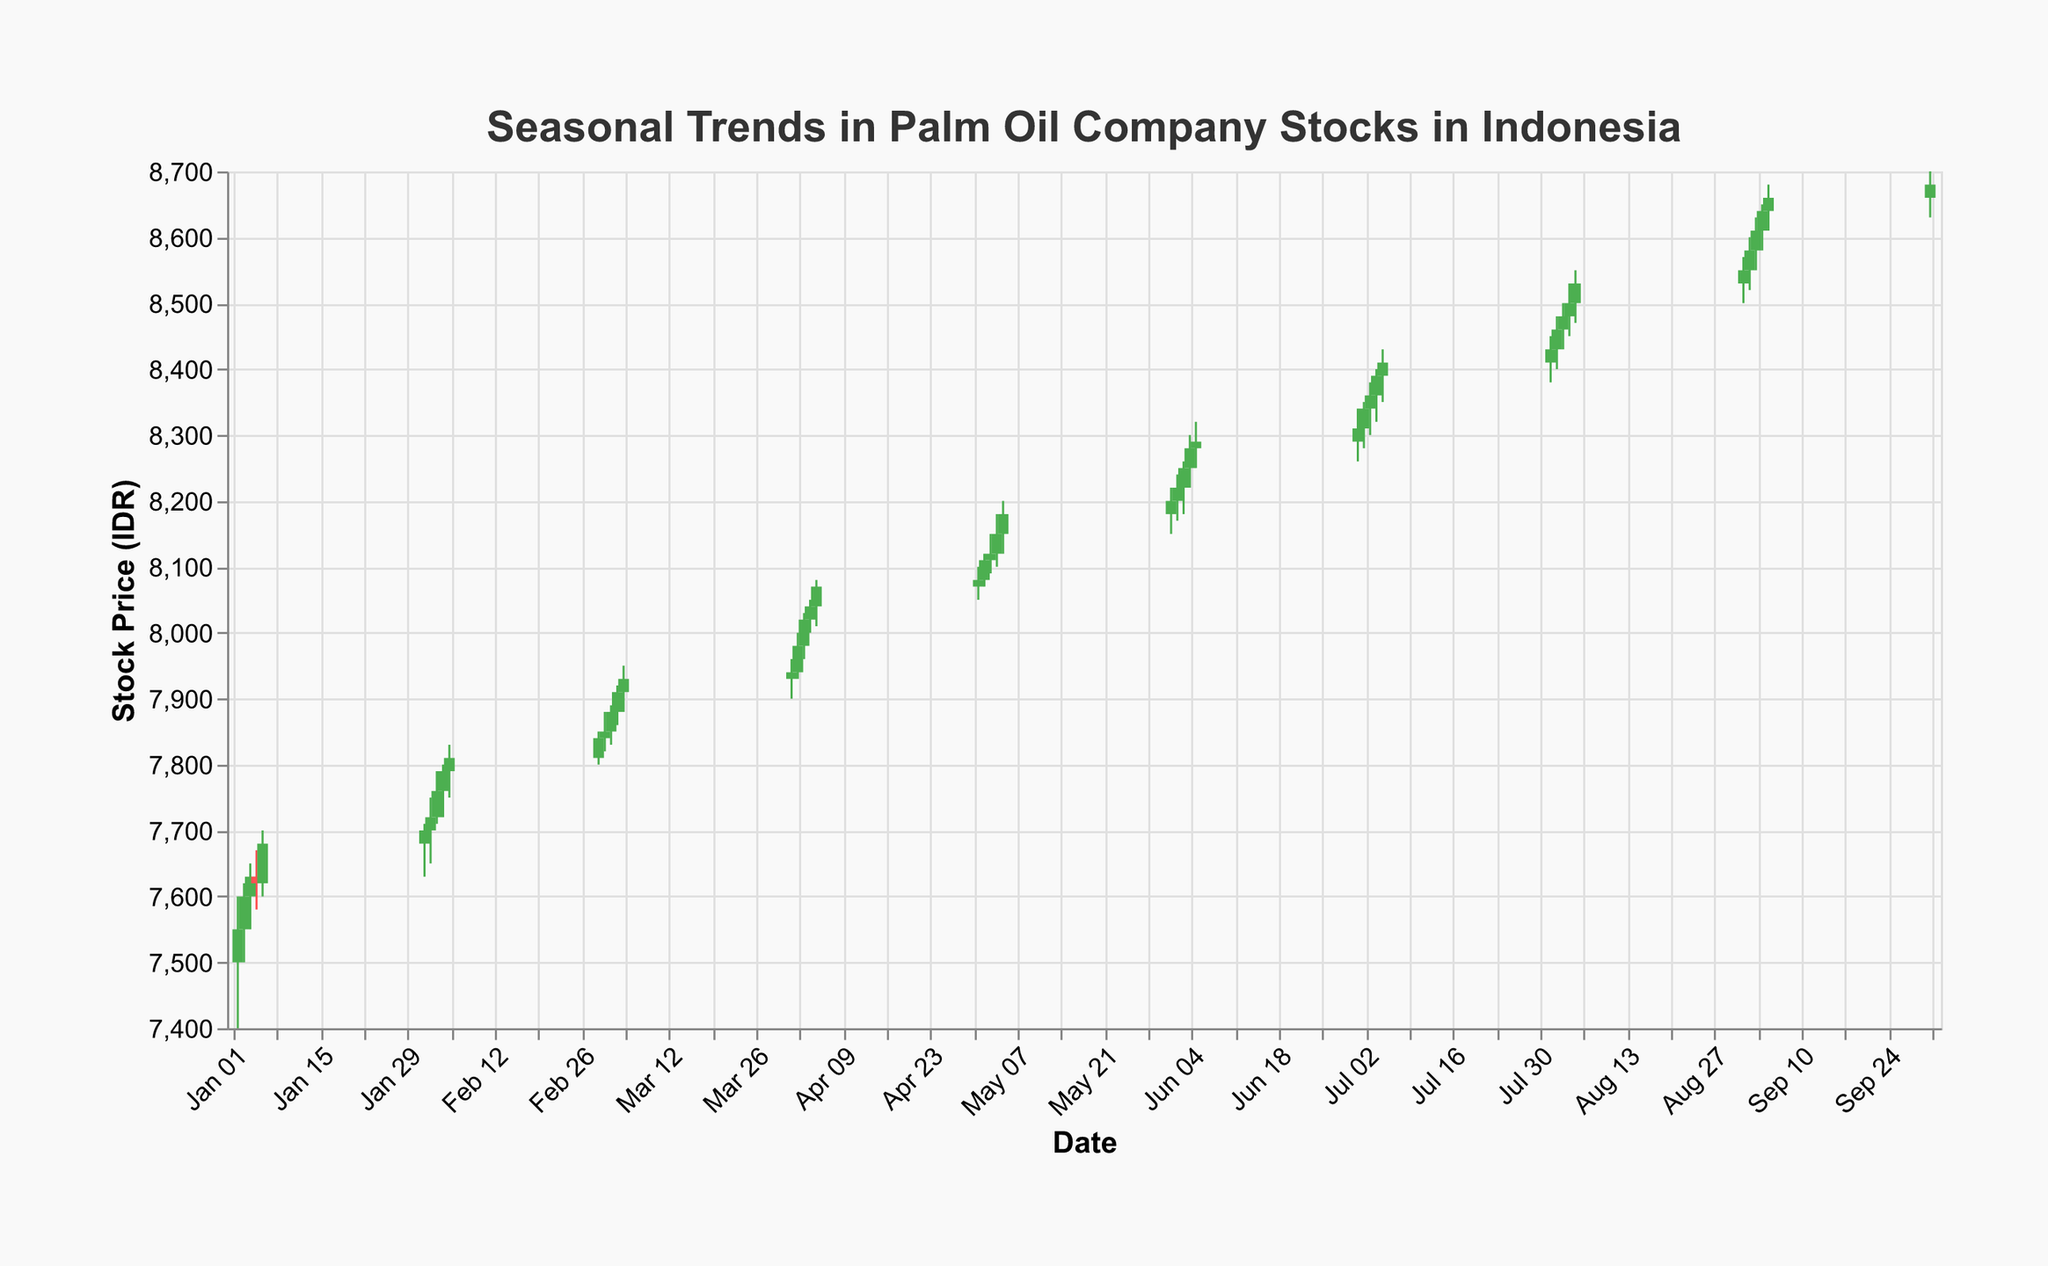What is the title of the figure? The title is usually displayed at the top of a figure and summarizes the content of the visualization. This figure's title reads "Seasonal Trends in Palm Oil Company Stocks in Indonesia."
Answer: Seasonal Trends in Palm Oil Company Stocks in Indonesia What does the y-axis represent? The y-axis typically indicates the quantity being measured in the figure. Here, it is labeled "Stock Price (IDR)," showing the stock prices in Indonesian Rupiah.
Answer: Stock Price (IDR) What color represents an increase in stock price? The color condition in the figure states that if the opening price is less than the closing price, the color will be green. This indicates an increase in stock price.
Answer: Green How many data points are shown for January 2023? We look at the dates and count the number of entries for January 2023. The data includes January 2nd to January 6th which totals to five points.
Answer: 5 Which month had the highest closing price, and what was that price? We identify the highest closing price and check the corresponding date. The highest closing price is on October 1, 2023, with a value of 8680 IDR.
Answer: October, 8680 IDR What is the range of stock prices on March 5, 2023? For the date March 5, 2023, we look at the 'Low' and 'High' values and find the range by subtracting the low value from the high value: (7950 - 7880).
Answer: 70 IDR Did the stock price always increase in July 2023? Comparing the opening and closing prices for each day in July 2023, we see that on July 1, July 2, July 3, July 4, and July 5, the closing prices were higher than the opening prices. Therefore, the stock price always increased.
Answer: Yes What is the average closing price for the first week of April 2023? Calculate the average by summing the closing prices from April 1 to April 5 and dividing by the number of closing values: (7940 + 7980 + 8020 + 8040 + 8070)/5 = 8010.
Answer: 8010 IDR When was the first time the closing price reached above 8000 IDR? Scanning the closing prices from the beginning of the year, the first date the closing price reached above 8000 IDR is April 3, 2023, with a closing price of 8020.
Answer: April 3, 2023 